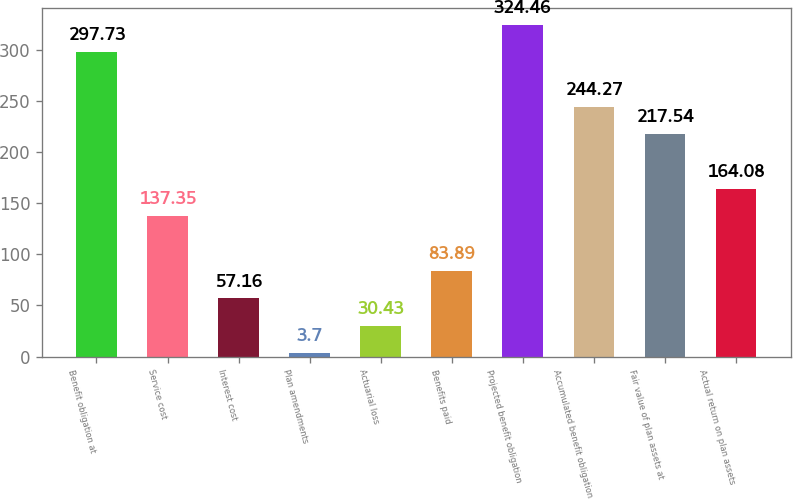Convert chart to OTSL. <chart><loc_0><loc_0><loc_500><loc_500><bar_chart><fcel>Benefit obligation at<fcel>Service cost<fcel>Interest cost<fcel>Plan amendments<fcel>Actuarial loss<fcel>Benefits paid<fcel>Projected benefit obligation<fcel>Accumulated benefit obligation<fcel>Fair value of plan assets at<fcel>Actual return on plan assets<nl><fcel>297.73<fcel>137.35<fcel>57.16<fcel>3.7<fcel>30.43<fcel>83.89<fcel>324.46<fcel>244.27<fcel>217.54<fcel>164.08<nl></chart> 